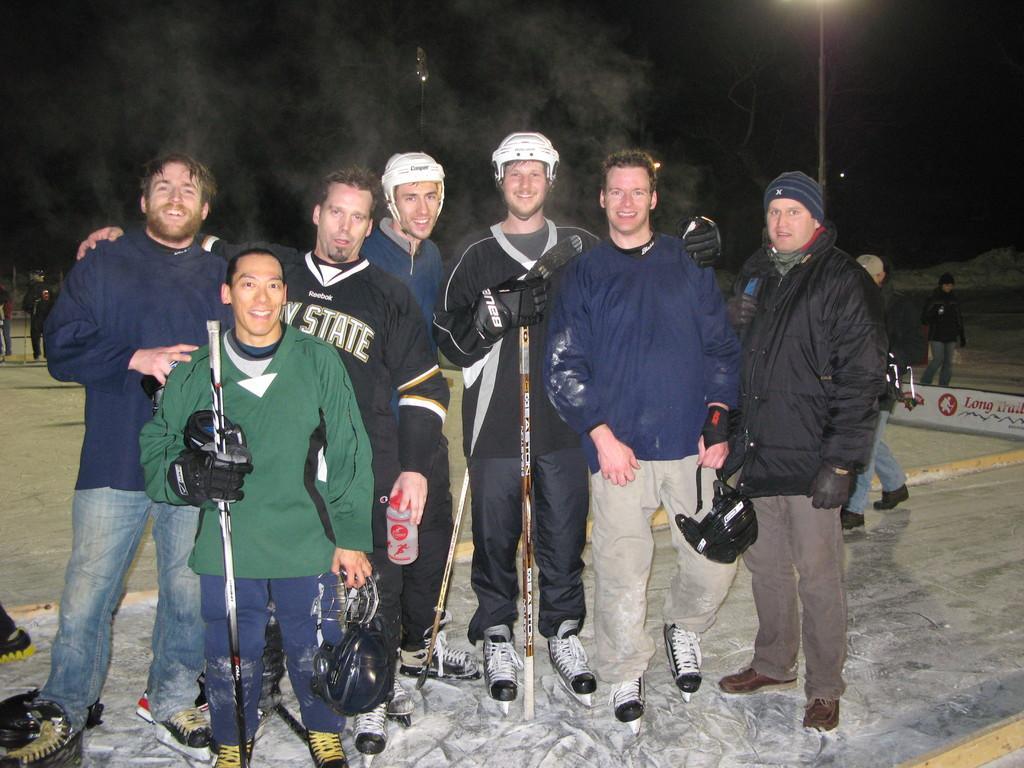In one or two sentences, can you explain what this image depicts? In this image I can see number of persons wearing jackets, pants, shoes are standing on the ground and I can see few of them are wearing white colored helmets. In the background I can see few persons standing, a pole, some smoke and the dark background. 